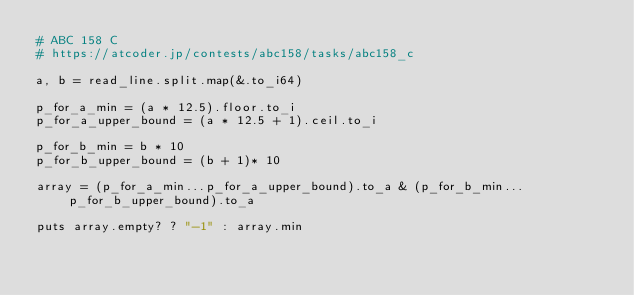Convert code to text. <code><loc_0><loc_0><loc_500><loc_500><_Crystal_># ABC 158 C
# https://atcoder.jp/contests/abc158/tasks/abc158_c

a, b = read_line.split.map(&.to_i64)

p_for_a_min = (a * 12.5).floor.to_i
p_for_a_upper_bound = (a * 12.5 + 1).ceil.to_i

p_for_b_min = b * 10
p_for_b_upper_bound = (b + 1)* 10

array = (p_for_a_min...p_for_a_upper_bound).to_a & (p_for_b_min...p_for_b_upper_bound).to_a

puts array.empty? ? "-1" : array.min
</code> 